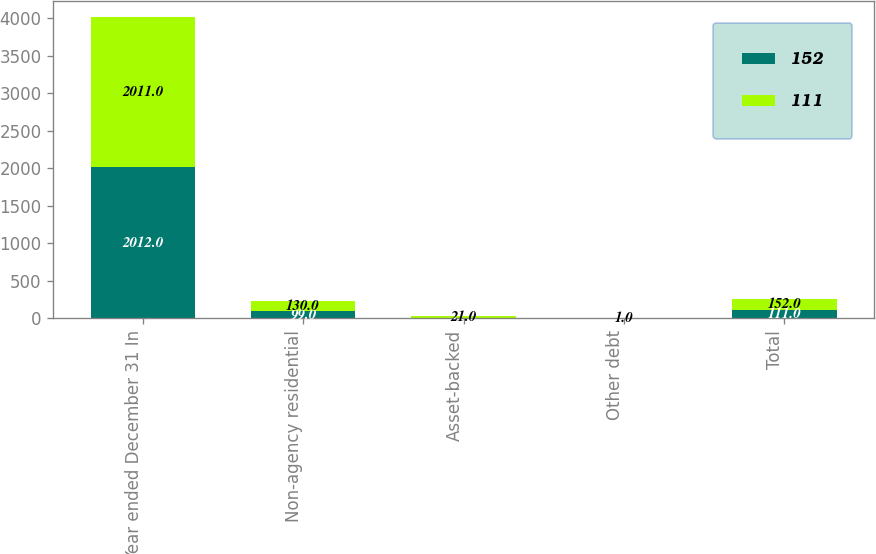Convert chart to OTSL. <chart><loc_0><loc_0><loc_500><loc_500><stacked_bar_chart><ecel><fcel>Year ended December 31 In<fcel>Non-agency residential<fcel>Asset-backed<fcel>Other debt<fcel>Total<nl><fcel>152<fcel>2012<fcel>99<fcel>11<fcel>1<fcel>111<nl><fcel>111<fcel>2011<fcel>130<fcel>21<fcel>1<fcel>152<nl></chart> 